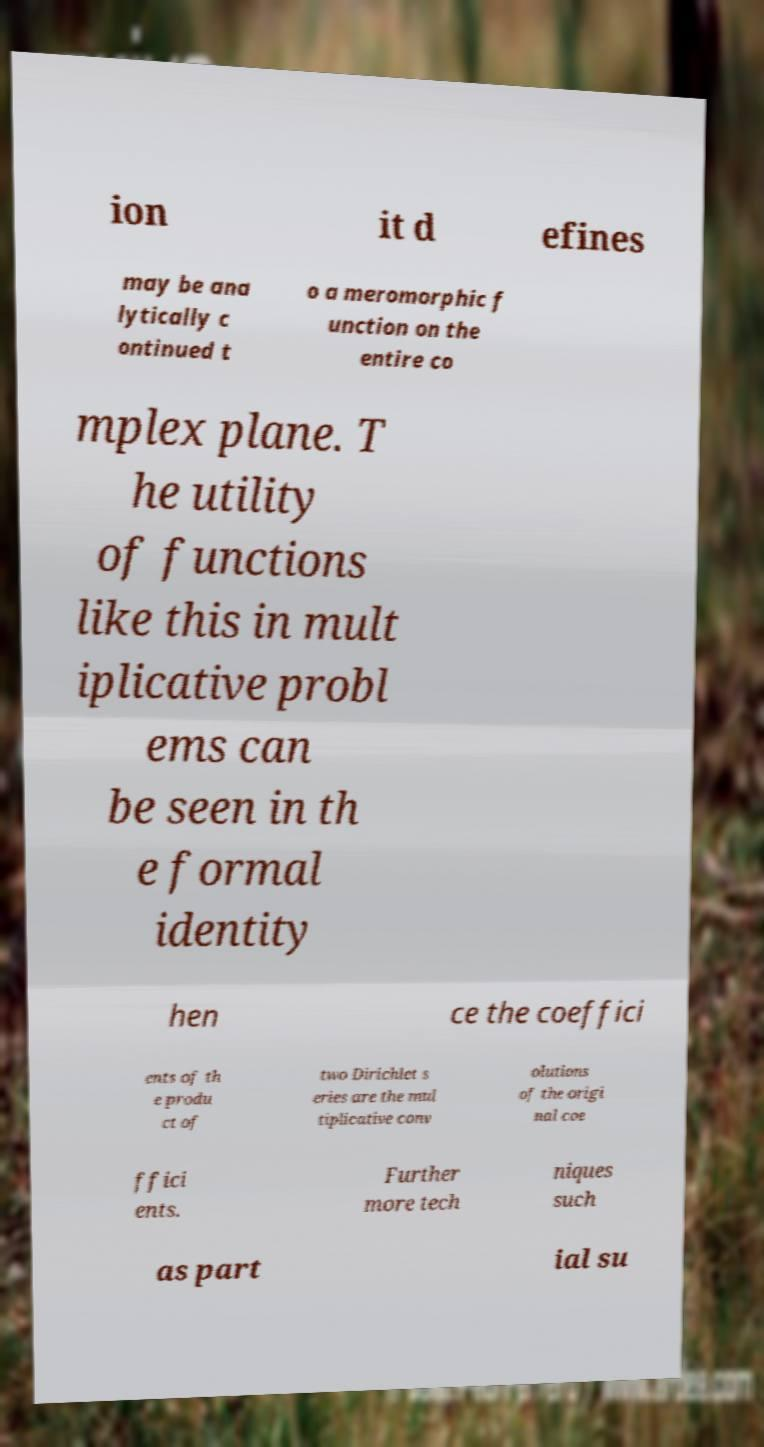Can you read and provide the text displayed in the image?This photo seems to have some interesting text. Can you extract and type it out for me? ion it d efines may be ana lytically c ontinued t o a meromorphic f unction on the entire co mplex plane. T he utility of functions like this in mult iplicative probl ems can be seen in th e formal identity hen ce the coeffici ents of th e produ ct of two Dirichlet s eries are the mul tiplicative conv olutions of the origi nal coe ffici ents. Further more tech niques such as part ial su 